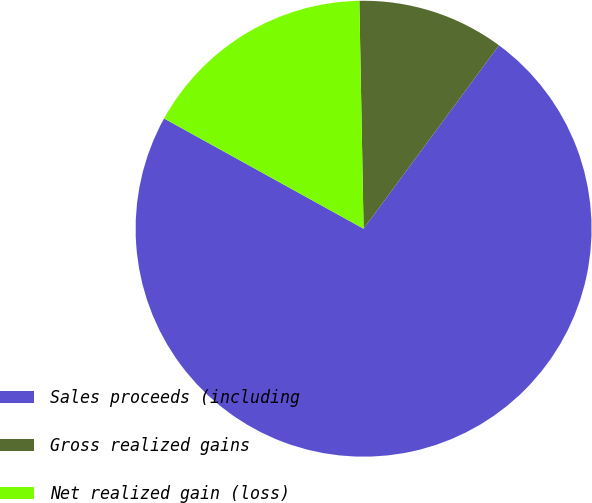<chart> <loc_0><loc_0><loc_500><loc_500><pie_chart><fcel>Sales proceeds (including<fcel>Gross realized gains<fcel>Net realized gain (loss)<nl><fcel>72.92%<fcel>10.42%<fcel>16.67%<nl></chart> 